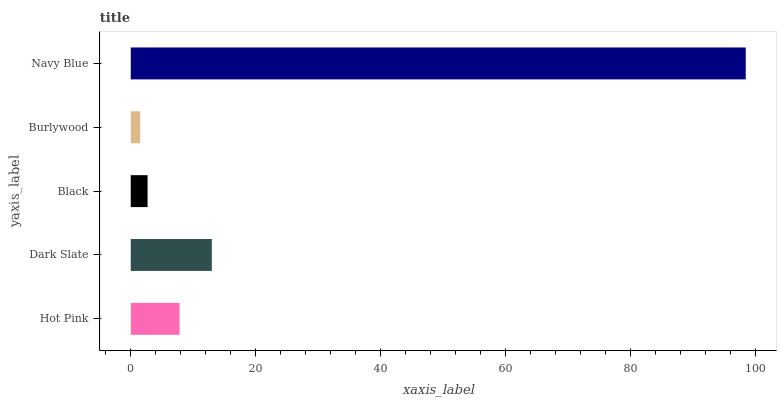Is Burlywood the minimum?
Answer yes or no. Yes. Is Navy Blue the maximum?
Answer yes or no. Yes. Is Dark Slate the minimum?
Answer yes or no. No. Is Dark Slate the maximum?
Answer yes or no. No. Is Dark Slate greater than Hot Pink?
Answer yes or no. Yes. Is Hot Pink less than Dark Slate?
Answer yes or no. Yes. Is Hot Pink greater than Dark Slate?
Answer yes or no. No. Is Dark Slate less than Hot Pink?
Answer yes or no. No. Is Hot Pink the high median?
Answer yes or no. Yes. Is Hot Pink the low median?
Answer yes or no. Yes. Is Black the high median?
Answer yes or no. No. Is Burlywood the low median?
Answer yes or no. No. 